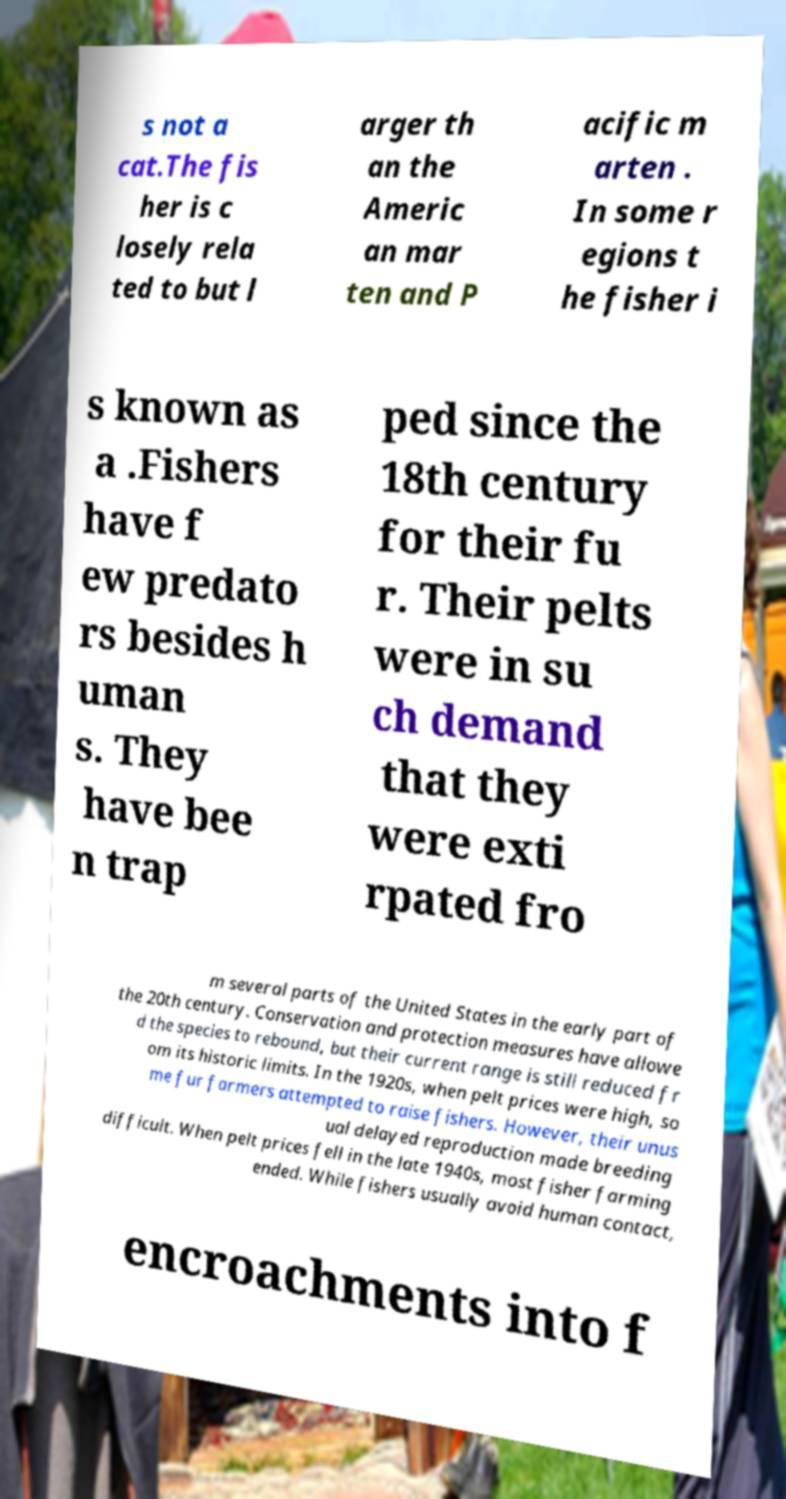Could you extract and type out the text from this image? s not a cat.The fis her is c losely rela ted to but l arger th an the Americ an mar ten and P acific m arten . In some r egions t he fisher i s known as a .Fishers have f ew predato rs besides h uman s. They have bee n trap ped since the 18th century for their fu r. Their pelts were in su ch demand that they were exti rpated fro m several parts of the United States in the early part of the 20th century. Conservation and protection measures have allowe d the species to rebound, but their current range is still reduced fr om its historic limits. In the 1920s, when pelt prices were high, so me fur farmers attempted to raise fishers. However, their unus ual delayed reproduction made breeding difficult. When pelt prices fell in the late 1940s, most fisher farming ended. While fishers usually avoid human contact, encroachments into f 